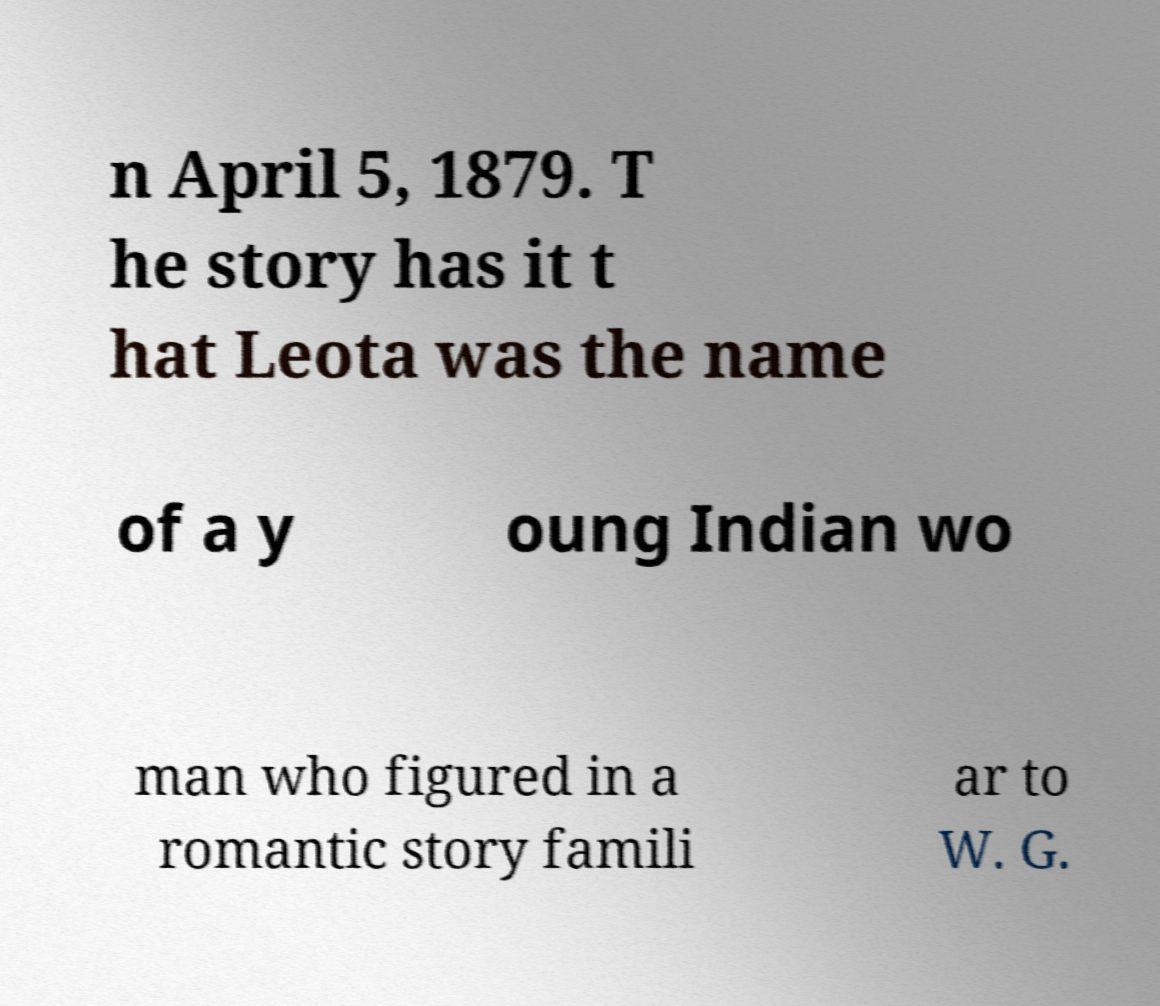Please read and relay the text visible in this image. What does it say? n April 5, 1879. T he story has it t hat Leota was the name of a y oung Indian wo man who figured in a romantic story famili ar to W. G. 